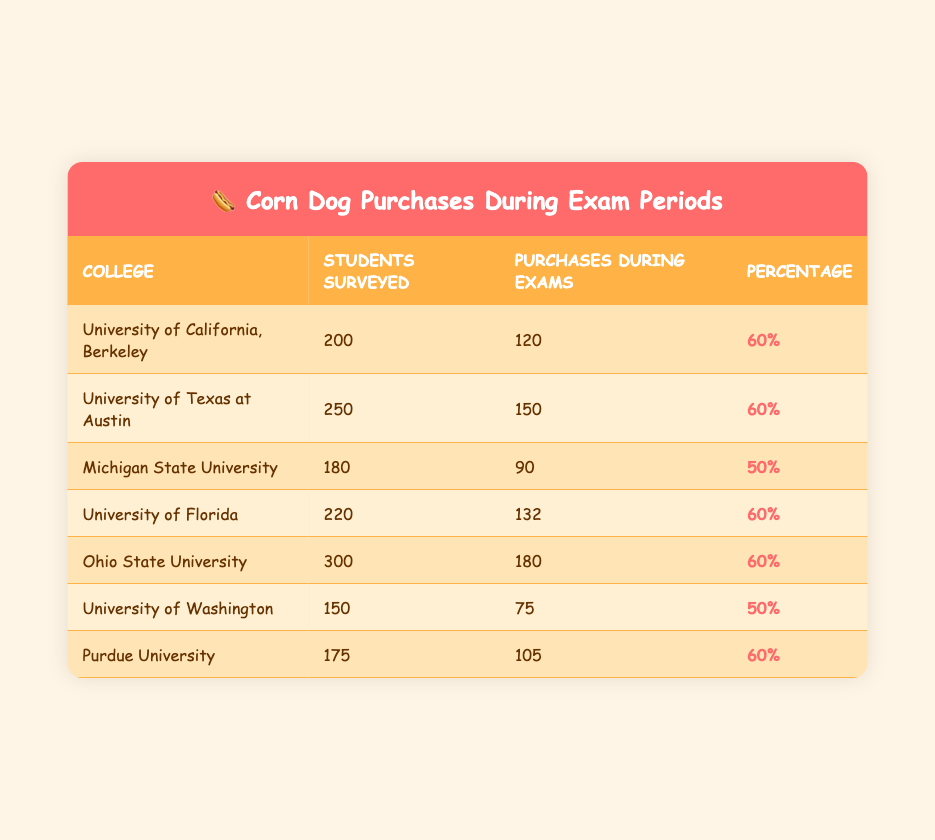What college had the highest number of students surveyed? Looking at the "Students Surveyed" column, Ohio State University has the highest number with 300 students
Answer: Ohio State University What percentage of students at Michigan State University purchased corn dogs during exams? Referring to the "Percentage" column for Michigan State University, it shows 50%
Answer: 50% How many total corn dog purchases were reported across all colleges during exams? Adding the "Purchases During Exams" values: 120 + 150 + 90 + 132 + 180 + 75 + 105 = 1052
Answer: 1052 Did more than half of the surveyed students at the University of California, Berkeley purchase corn dogs during exams? Yes, 60% of the students surveyed purchased corn dogs during exams, which is more than half
Answer: Yes Which colleges had a purchase percentage of 60%? Reference the "Percentage" column for the respective colleges: University of California, Berkeley; University of Texas at Austin; University of Florida; Ohio State University; and Purdue University all have 60%
Answer: University of California, Berkeley; University of Texas at Austin; University of Florida; Ohio State University; Purdue University What is the average percentage of corn dog purchases during exams across all colleges? To calculate the average: (60 + 60 + 50 + 60 + 60 + 50 + 60) / 7 = 57.14%. Therefore, the average percentage is approximately 57.14%
Answer: 57.14% Which college had the fewest purchases during exams? The college with the fewest purchases during exams, according to the table, is the University of Washington with 75 purchases
Answer: University of Washington Did the University of Florida survey a larger number of students than Michigan State University? Yes, University of Florida surveyed 220 students while Michigan State University surveyed 180
Answer: Yes What is the difference in corn dog purchases during exams between Ohio State University and Michigan State University? The difference is calculated by subtracting Michigan State University purchases (90) from Ohio State University purchases (180): 180 - 90 = 90
Answer: 90 